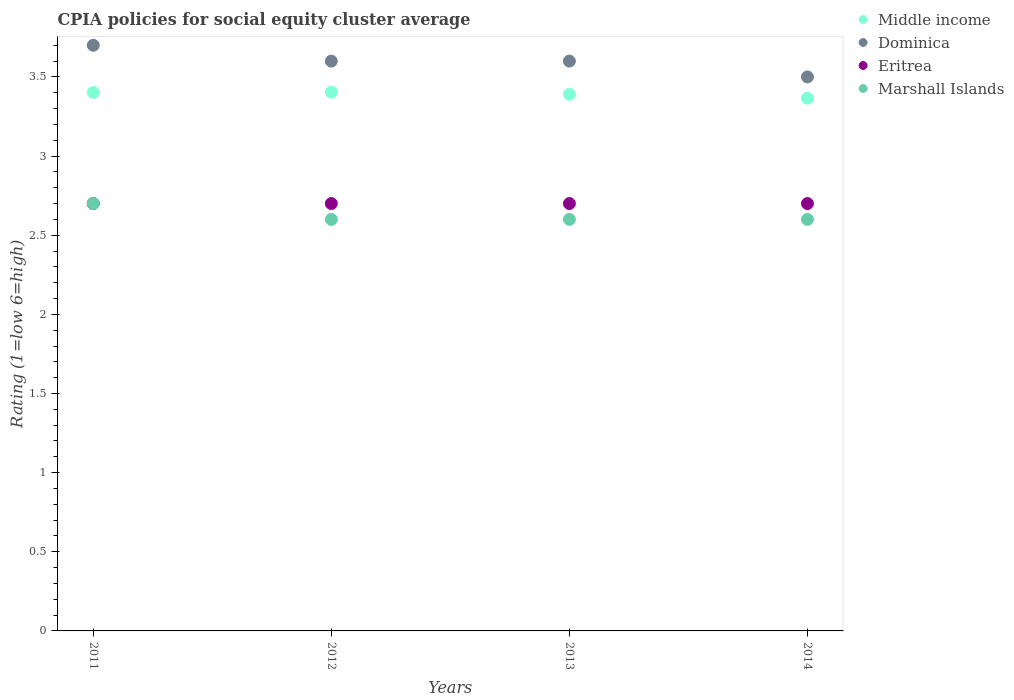How many different coloured dotlines are there?
Provide a short and direct response. 4. Is the number of dotlines equal to the number of legend labels?
Your response must be concise. Yes. What is the CPIA rating in Eritrea in 2012?
Keep it short and to the point. 2.7. Across all years, what is the maximum CPIA rating in Dominica?
Give a very brief answer. 3.7. Across all years, what is the minimum CPIA rating in Middle income?
Your answer should be compact. 3.37. In which year was the CPIA rating in Eritrea minimum?
Offer a terse response. 2011. What is the difference between the CPIA rating in Dominica in 2011 and that in 2012?
Your answer should be very brief. 0.1. What is the difference between the CPIA rating in Dominica in 2011 and the CPIA rating in Middle income in 2013?
Offer a very short reply. 0.31. What is the average CPIA rating in Marshall Islands per year?
Offer a very short reply. 2.62. In the year 2013, what is the difference between the CPIA rating in Marshall Islands and CPIA rating in Dominica?
Ensure brevity in your answer.  -1. What is the ratio of the CPIA rating in Middle income in 2012 to that in 2014?
Ensure brevity in your answer.  1.01. Is the CPIA rating in Dominica in 2012 less than that in 2013?
Keep it short and to the point. No. What is the difference between the highest and the second highest CPIA rating in Middle income?
Your response must be concise. 0. What is the difference between the highest and the lowest CPIA rating in Eritrea?
Provide a succinct answer. 0. In how many years, is the CPIA rating in Marshall Islands greater than the average CPIA rating in Marshall Islands taken over all years?
Offer a terse response. 1. Is the CPIA rating in Middle income strictly greater than the CPIA rating in Marshall Islands over the years?
Offer a terse response. Yes. Is the CPIA rating in Marshall Islands strictly less than the CPIA rating in Middle income over the years?
Offer a very short reply. Yes. How many dotlines are there?
Make the answer very short. 4. Does the graph contain any zero values?
Make the answer very short. No. What is the title of the graph?
Provide a succinct answer. CPIA policies for social equity cluster average. Does "Nepal" appear as one of the legend labels in the graph?
Your response must be concise. No. What is the label or title of the X-axis?
Offer a very short reply. Years. What is the label or title of the Y-axis?
Offer a terse response. Rating (1=low 6=high). What is the Rating (1=low 6=high) of Middle income in 2011?
Your answer should be very brief. 3.4. What is the Rating (1=low 6=high) in Dominica in 2011?
Offer a terse response. 3.7. What is the Rating (1=low 6=high) of Eritrea in 2011?
Offer a very short reply. 2.7. What is the Rating (1=low 6=high) in Marshall Islands in 2011?
Your answer should be compact. 2.7. What is the Rating (1=low 6=high) of Middle income in 2012?
Your answer should be very brief. 3.4. What is the Rating (1=low 6=high) in Eritrea in 2012?
Offer a terse response. 2.7. What is the Rating (1=low 6=high) of Marshall Islands in 2012?
Offer a very short reply. 2.6. What is the Rating (1=low 6=high) in Middle income in 2013?
Your response must be concise. 3.39. What is the Rating (1=low 6=high) in Marshall Islands in 2013?
Offer a very short reply. 2.6. What is the Rating (1=low 6=high) in Middle income in 2014?
Ensure brevity in your answer.  3.37. What is the Rating (1=low 6=high) of Eritrea in 2014?
Your answer should be compact. 2.7. What is the Rating (1=low 6=high) in Marshall Islands in 2014?
Your response must be concise. 2.6. Across all years, what is the maximum Rating (1=low 6=high) in Middle income?
Your answer should be compact. 3.4. Across all years, what is the minimum Rating (1=low 6=high) in Middle income?
Offer a very short reply. 3.37. Across all years, what is the minimum Rating (1=low 6=high) of Dominica?
Your response must be concise. 3.5. What is the total Rating (1=low 6=high) in Middle income in the graph?
Keep it short and to the point. 13.56. What is the total Rating (1=low 6=high) in Dominica in the graph?
Make the answer very short. 14.4. What is the total Rating (1=low 6=high) in Eritrea in the graph?
Your answer should be compact. 10.8. What is the total Rating (1=low 6=high) in Marshall Islands in the graph?
Offer a terse response. 10.5. What is the difference between the Rating (1=low 6=high) of Middle income in 2011 and that in 2012?
Offer a terse response. -0. What is the difference between the Rating (1=low 6=high) of Eritrea in 2011 and that in 2012?
Offer a terse response. 0. What is the difference between the Rating (1=low 6=high) in Middle income in 2011 and that in 2013?
Your answer should be compact. 0.01. What is the difference between the Rating (1=low 6=high) in Middle income in 2011 and that in 2014?
Make the answer very short. 0.04. What is the difference between the Rating (1=low 6=high) of Marshall Islands in 2011 and that in 2014?
Offer a terse response. 0.1. What is the difference between the Rating (1=low 6=high) of Middle income in 2012 and that in 2013?
Your response must be concise. 0.01. What is the difference between the Rating (1=low 6=high) in Dominica in 2012 and that in 2013?
Your answer should be compact. 0. What is the difference between the Rating (1=low 6=high) of Middle income in 2012 and that in 2014?
Your answer should be compact. 0.04. What is the difference between the Rating (1=low 6=high) in Dominica in 2012 and that in 2014?
Keep it short and to the point. 0.1. What is the difference between the Rating (1=low 6=high) in Eritrea in 2012 and that in 2014?
Give a very brief answer. 0. What is the difference between the Rating (1=low 6=high) in Middle income in 2013 and that in 2014?
Make the answer very short. 0.02. What is the difference between the Rating (1=low 6=high) of Dominica in 2013 and that in 2014?
Offer a terse response. 0.1. What is the difference between the Rating (1=low 6=high) in Middle income in 2011 and the Rating (1=low 6=high) in Dominica in 2012?
Your answer should be very brief. -0.2. What is the difference between the Rating (1=low 6=high) of Middle income in 2011 and the Rating (1=low 6=high) of Eritrea in 2012?
Offer a very short reply. 0.7. What is the difference between the Rating (1=low 6=high) in Middle income in 2011 and the Rating (1=low 6=high) in Marshall Islands in 2012?
Provide a short and direct response. 0.8. What is the difference between the Rating (1=low 6=high) in Dominica in 2011 and the Rating (1=low 6=high) in Marshall Islands in 2012?
Offer a terse response. 1.1. What is the difference between the Rating (1=low 6=high) of Middle income in 2011 and the Rating (1=low 6=high) of Dominica in 2013?
Provide a succinct answer. -0.2. What is the difference between the Rating (1=low 6=high) of Middle income in 2011 and the Rating (1=low 6=high) of Eritrea in 2013?
Your answer should be compact. 0.7. What is the difference between the Rating (1=low 6=high) of Middle income in 2011 and the Rating (1=low 6=high) of Marshall Islands in 2013?
Ensure brevity in your answer.  0.8. What is the difference between the Rating (1=low 6=high) of Dominica in 2011 and the Rating (1=low 6=high) of Eritrea in 2013?
Provide a short and direct response. 1. What is the difference between the Rating (1=low 6=high) in Middle income in 2011 and the Rating (1=low 6=high) in Dominica in 2014?
Make the answer very short. -0.1. What is the difference between the Rating (1=low 6=high) of Middle income in 2011 and the Rating (1=low 6=high) of Eritrea in 2014?
Provide a short and direct response. 0.7. What is the difference between the Rating (1=low 6=high) in Middle income in 2011 and the Rating (1=low 6=high) in Marshall Islands in 2014?
Your response must be concise. 0.8. What is the difference between the Rating (1=low 6=high) in Dominica in 2011 and the Rating (1=low 6=high) in Marshall Islands in 2014?
Ensure brevity in your answer.  1.1. What is the difference between the Rating (1=low 6=high) of Eritrea in 2011 and the Rating (1=low 6=high) of Marshall Islands in 2014?
Provide a short and direct response. 0.1. What is the difference between the Rating (1=low 6=high) in Middle income in 2012 and the Rating (1=low 6=high) in Dominica in 2013?
Give a very brief answer. -0.2. What is the difference between the Rating (1=low 6=high) of Middle income in 2012 and the Rating (1=low 6=high) of Eritrea in 2013?
Your answer should be compact. 0.7. What is the difference between the Rating (1=low 6=high) in Middle income in 2012 and the Rating (1=low 6=high) in Marshall Islands in 2013?
Offer a very short reply. 0.8. What is the difference between the Rating (1=low 6=high) in Dominica in 2012 and the Rating (1=low 6=high) in Eritrea in 2013?
Provide a succinct answer. 0.9. What is the difference between the Rating (1=low 6=high) in Dominica in 2012 and the Rating (1=low 6=high) in Marshall Islands in 2013?
Your answer should be compact. 1. What is the difference between the Rating (1=low 6=high) in Middle income in 2012 and the Rating (1=low 6=high) in Dominica in 2014?
Offer a very short reply. -0.1. What is the difference between the Rating (1=low 6=high) in Middle income in 2012 and the Rating (1=low 6=high) in Eritrea in 2014?
Provide a succinct answer. 0.7. What is the difference between the Rating (1=low 6=high) of Middle income in 2012 and the Rating (1=low 6=high) of Marshall Islands in 2014?
Offer a terse response. 0.8. What is the difference between the Rating (1=low 6=high) in Dominica in 2012 and the Rating (1=low 6=high) in Marshall Islands in 2014?
Your answer should be compact. 1. What is the difference between the Rating (1=low 6=high) of Eritrea in 2012 and the Rating (1=low 6=high) of Marshall Islands in 2014?
Keep it short and to the point. 0.1. What is the difference between the Rating (1=low 6=high) in Middle income in 2013 and the Rating (1=low 6=high) in Dominica in 2014?
Your answer should be very brief. -0.11. What is the difference between the Rating (1=low 6=high) in Middle income in 2013 and the Rating (1=low 6=high) in Eritrea in 2014?
Your answer should be very brief. 0.69. What is the difference between the Rating (1=low 6=high) in Middle income in 2013 and the Rating (1=low 6=high) in Marshall Islands in 2014?
Your answer should be very brief. 0.79. What is the difference between the Rating (1=low 6=high) in Dominica in 2013 and the Rating (1=low 6=high) in Eritrea in 2014?
Ensure brevity in your answer.  0.9. What is the average Rating (1=low 6=high) of Middle income per year?
Your response must be concise. 3.39. What is the average Rating (1=low 6=high) of Dominica per year?
Make the answer very short. 3.6. What is the average Rating (1=low 6=high) of Eritrea per year?
Keep it short and to the point. 2.7. What is the average Rating (1=low 6=high) in Marshall Islands per year?
Offer a very short reply. 2.62. In the year 2011, what is the difference between the Rating (1=low 6=high) in Middle income and Rating (1=low 6=high) in Dominica?
Ensure brevity in your answer.  -0.3. In the year 2011, what is the difference between the Rating (1=low 6=high) of Middle income and Rating (1=low 6=high) of Eritrea?
Make the answer very short. 0.7. In the year 2011, what is the difference between the Rating (1=low 6=high) of Middle income and Rating (1=low 6=high) of Marshall Islands?
Give a very brief answer. 0.7. In the year 2011, what is the difference between the Rating (1=low 6=high) in Dominica and Rating (1=low 6=high) in Eritrea?
Offer a very short reply. 1. In the year 2011, what is the difference between the Rating (1=low 6=high) of Dominica and Rating (1=low 6=high) of Marshall Islands?
Your answer should be very brief. 1. In the year 2011, what is the difference between the Rating (1=low 6=high) in Eritrea and Rating (1=low 6=high) in Marshall Islands?
Offer a very short reply. 0. In the year 2012, what is the difference between the Rating (1=low 6=high) of Middle income and Rating (1=low 6=high) of Dominica?
Your response must be concise. -0.2. In the year 2012, what is the difference between the Rating (1=low 6=high) in Middle income and Rating (1=low 6=high) in Eritrea?
Your answer should be very brief. 0.7. In the year 2012, what is the difference between the Rating (1=low 6=high) in Middle income and Rating (1=low 6=high) in Marshall Islands?
Keep it short and to the point. 0.8. In the year 2012, what is the difference between the Rating (1=low 6=high) in Dominica and Rating (1=low 6=high) in Marshall Islands?
Provide a short and direct response. 1. In the year 2013, what is the difference between the Rating (1=low 6=high) of Middle income and Rating (1=low 6=high) of Dominica?
Offer a very short reply. -0.21. In the year 2013, what is the difference between the Rating (1=low 6=high) of Middle income and Rating (1=low 6=high) of Eritrea?
Your answer should be compact. 0.69. In the year 2013, what is the difference between the Rating (1=low 6=high) of Middle income and Rating (1=low 6=high) of Marshall Islands?
Ensure brevity in your answer.  0.79. In the year 2013, what is the difference between the Rating (1=low 6=high) in Dominica and Rating (1=low 6=high) in Marshall Islands?
Give a very brief answer. 1. In the year 2014, what is the difference between the Rating (1=low 6=high) of Middle income and Rating (1=low 6=high) of Dominica?
Your response must be concise. -0.13. In the year 2014, what is the difference between the Rating (1=low 6=high) of Middle income and Rating (1=low 6=high) of Eritrea?
Provide a short and direct response. 0.67. In the year 2014, what is the difference between the Rating (1=low 6=high) in Middle income and Rating (1=low 6=high) in Marshall Islands?
Provide a short and direct response. 0.77. What is the ratio of the Rating (1=low 6=high) in Middle income in 2011 to that in 2012?
Ensure brevity in your answer.  1. What is the ratio of the Rating (1=low 6=high) in Dominica in 2011 to that in 2012?
Make the answer very short. 1.03. What is the ratio of the Rating (1=low 6=high) of Eritrea in 2011 to that in 2012?
Your response must be concise. 1. What is the ratio of the Rating (1=low 6=high) in Dominica in 2011 to that in 2013?
Your answer should be compact. 1.03. What is the ratio of the Rating (1=low 6=high) in Eritrea in 2011 to that in 2013?
Provide a short and direct response. 1. What is the ratio of the Rating (1=low 6=high) in Marshall Islands in 2011 to that in 2013?
Make the answer very short. 1.04. What is the ratio of the Rating (1=low 6=high) of Middle income in 2011 to that in 2014?
Offer a terse response. 1.01. What is the ratio of the Rating (1=low 6=high) of Dominica in 2011 to that in 2014?
Give a very brief answer. 1.06. What is the ratio of the Rating (1=low 6=high) of Eritrea in 2011 to that in 2014?
Make the answer very short. 1. What is the ratio of the Rating (1=low 6=high) in Marshall Islands in 2011 to that in 2014?
Ensure brevity in your answer.  1.04. What is the ratio of the Rating (1=low 6=high) of Middle income in 2012 to that in 2013?
Keep it short and to the point. 1. What is the ratio of the Rating (1=low 6=high) of Dominica in 2012 to that in 2013?
Provide a succinct answer. 1. What is the ratio of the Rating (1=low 6=high) of Marshall Islands in 2012 to that in 2013?
Offer a terse response. 1. What is the ratio of the Rating (1=low 6=high) of Middle income in 2012 to that in 2014?
Provide a succinct answer. 1.01. What is the ratio of the Rating (1=low 6=high) in Dominica in 2012 to that in 2014?
Offer a very short reply. 1.03. What is the ratio of the Rating (1=low 6=high) in Marshall Islands in 2012 to that in 2014?
Offer a very short reply. 1. What is the ratio of the Rating (1=low 6=high) of Middle income in 2013 to that in 2014?
Provide a succinct answer. 1.01. What is the ratio of the Rating (1=low 6=high) in Dominica in 2013 to that in 2014?
Provide a succinct answer. 1.03. What is the ratio of the Rating (1=low 6=high) in Eritrea in 2013 to that in 2014?
Offer a very short reply. 1. What is the ratio of the Rating (1=low 6=high) of Marshall Islands in 2013 to that in 2014?
Give a very brief answer. 1. What is the difference between the highest and the second highest Rating (1=low 6=high) of Middle income?
Ensure brevity in your answer.  0. What is the difference between the highest and the lowest Rating (1=low 6=high) in Middle income?
Offer a very short reply. 0.04. What is the difference between the highest and the lowest Rating (1=low 6=high) of Eritrea?
Keep it short and to the point. 0. What is the difference between the highest and the lowest Rating (1=low 6=high) of Marshall Islands?
Ensure brevity in your answer.  0.1. 